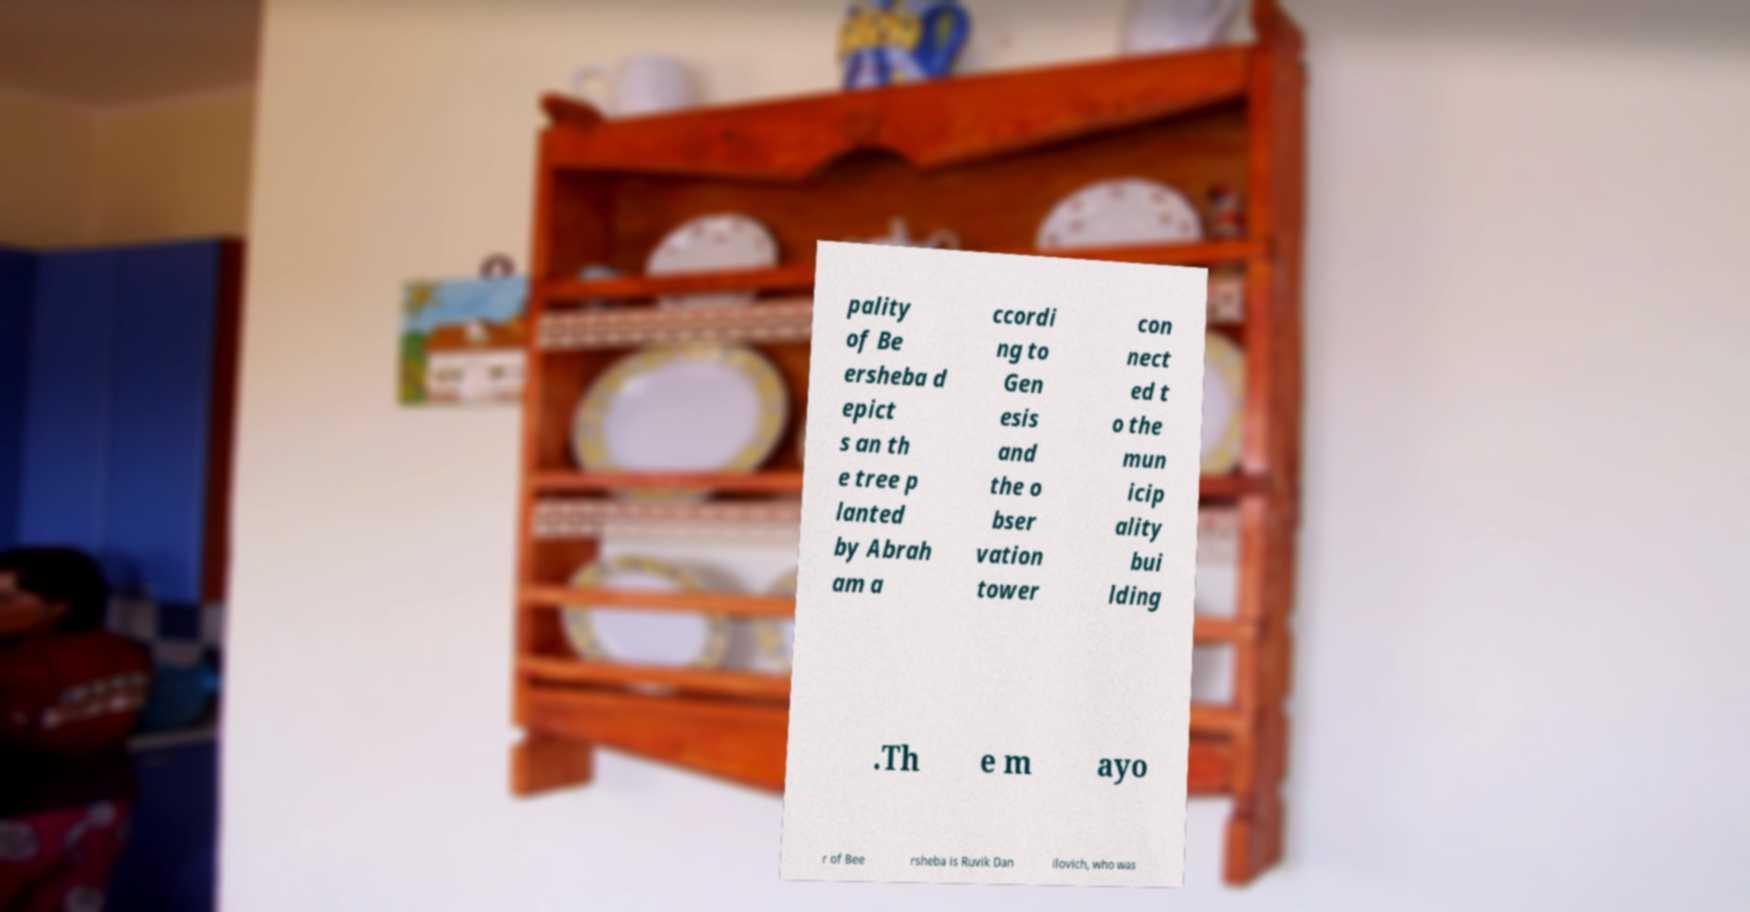Can you read and provide the text displayed in the image?This photo seems to have some interesting text. Can you extract and type it out for me? pality of Be ersheba d epict s an th e tree p lanted by Abrah am a ccordi ng to Gen esis and the o bser vation tower con nect ed t o the mun icip ality bui lding .Th e m ayo r of Bee rsheba is Ruvik Dan ilovich, who was 